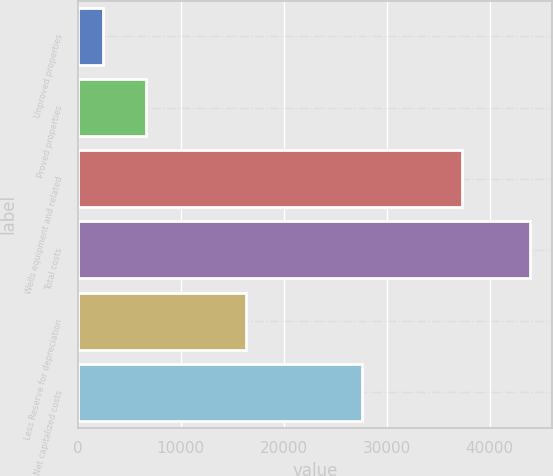Convert chart to OTSL. <chart><loc_0><loc_0><loc_500><loc_500><bar_chart><fcel>Unproved properties<fcel>Proved properties<fcel>Wells equipment and related<fcel>Total costs<fcel>Less Reserve for depreciation<fcel>Net capitalized costs<nl><fcel>2460<fcel>6599.5<fcel>37274<fcel>43855<fcel>16298<fcel>27557<nl></chart> 